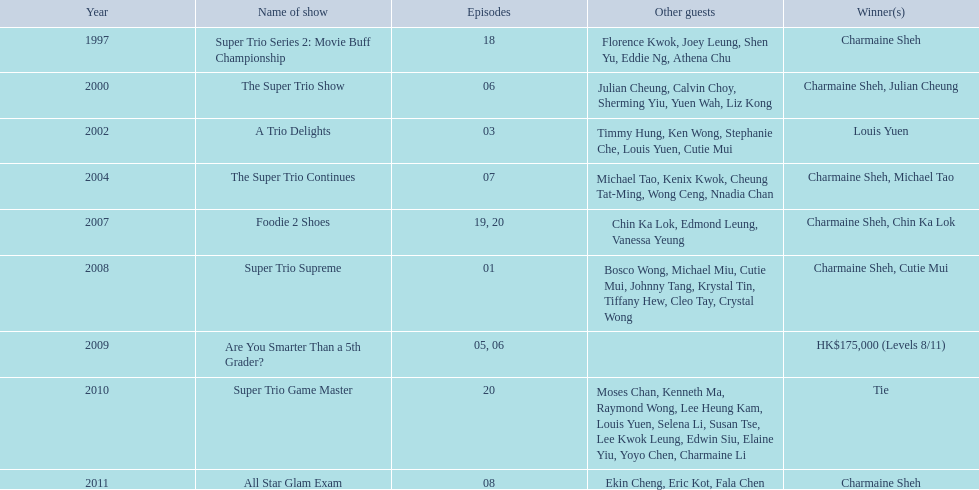In how many television series has charmaine sheh made appearances? 9. 